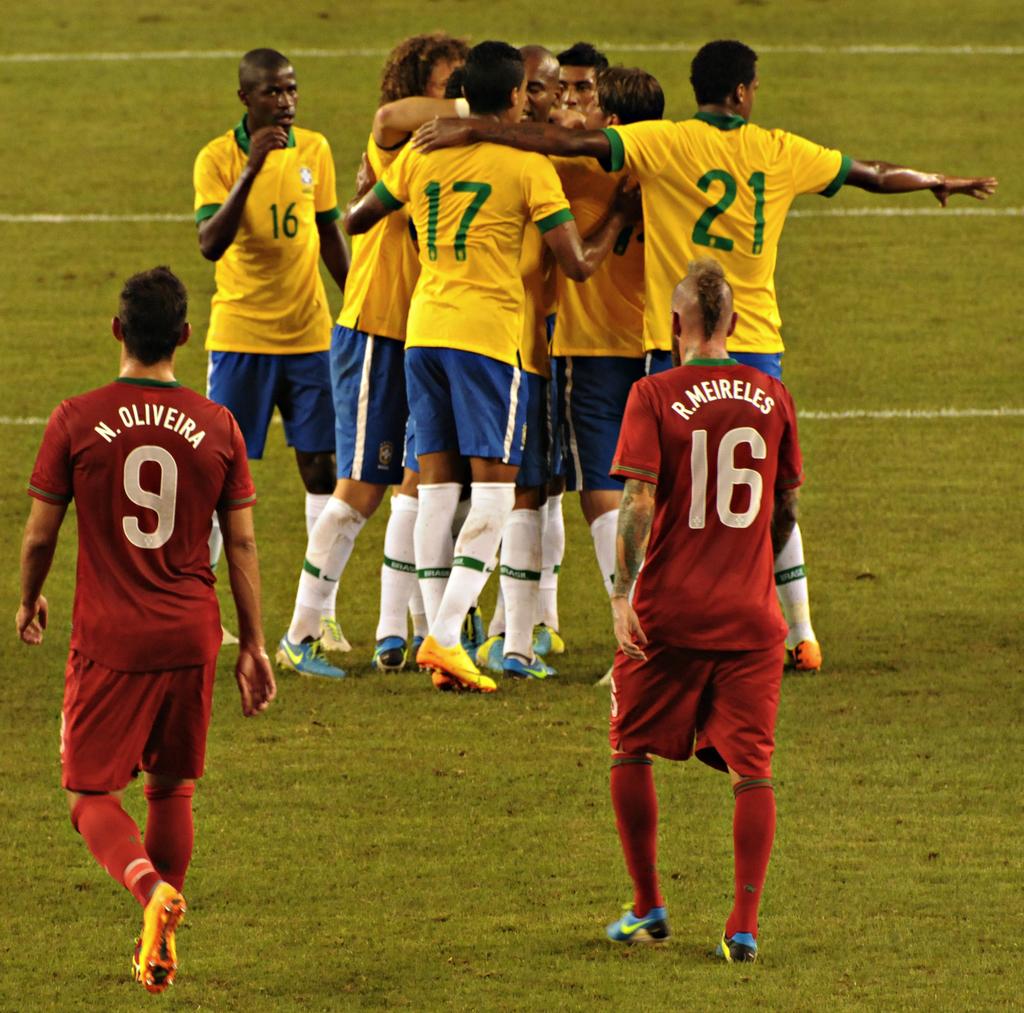What are the two numbers of the red shirted players?
Your answer should be compact. 9 16. What is the number of the yellow shirt guy on the far right?
Offer a terse response. 21. 